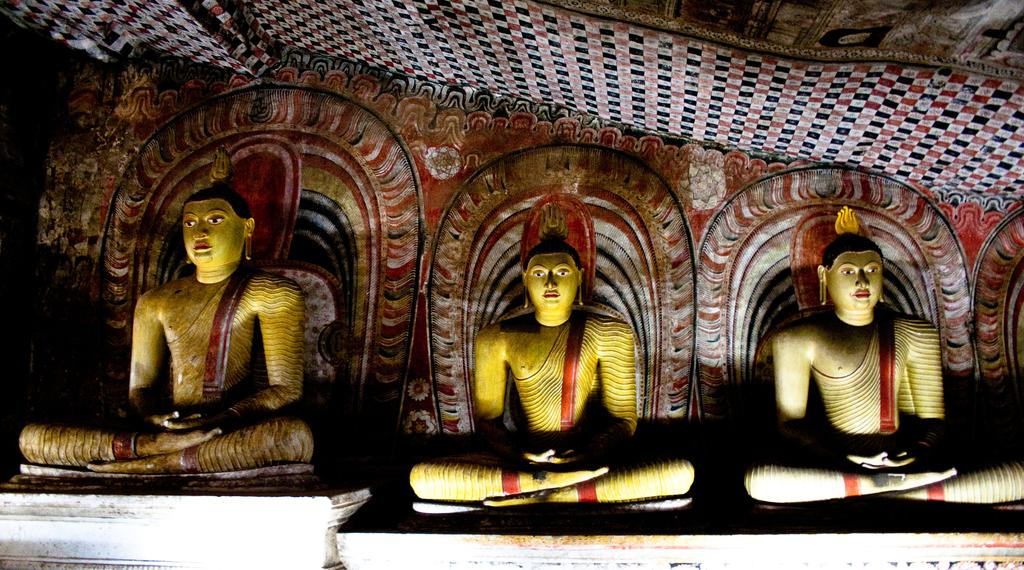How many statues are present in the image? There are three statues in the image. Can you describe the object that resembles a cloth at the top of the image? Yes, there is an object that looks like a cloth at the top of the image. How many rabbits can be seen wearing masks in the image? There are no rabbits or masks present in the image. What type of mine is depicted in the image? There is no mine present in the image. 